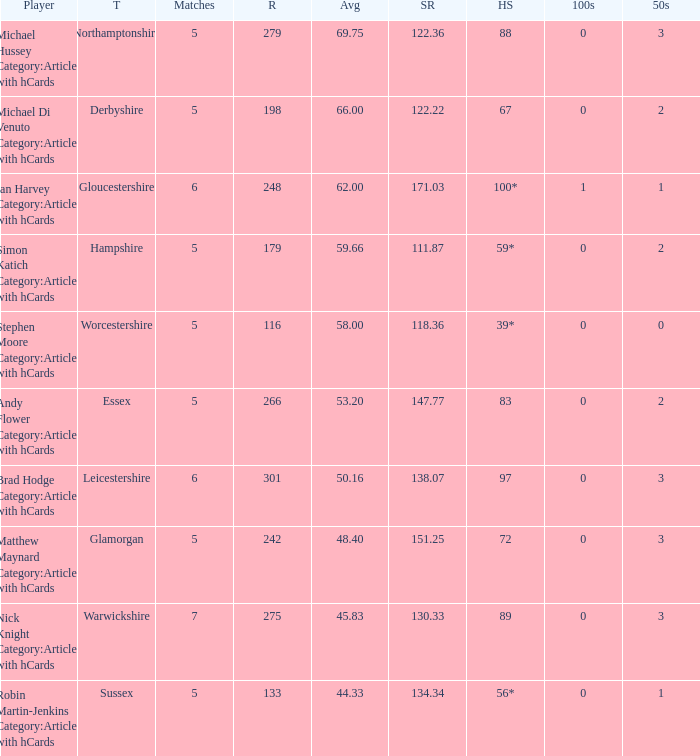If the highest score is 88, what are the 50s? 3.0. 